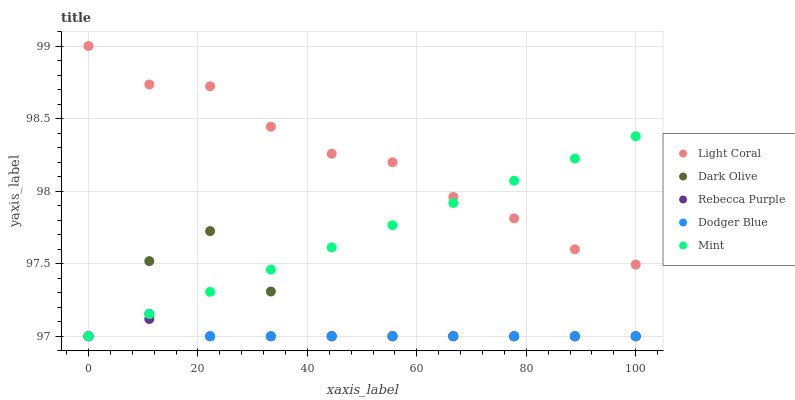Does Rebecca Purple have the minimum area under the curve?
Answer yes or no. Yes. Does Light Coral have the maximum area under the curve?
Answer yes or no. Yes. Does Mint have the minimum area under the curve?
Answer yes or no. No. Does Mint have the maximum area under the curve?
Answer yes or no. No. Is Mint the smoothest?
Answer yes or no. Yes. Is Dark Olive the roughest?
Answer yes or no. Yes. Is Dark Olive the smoothest?
Answer yes or no. No. Is Mint the roughest?
Answer yes or no. No. Does Mint have the lowest value?
Answer yes or no. Yes. Does Light Coral have the highest value?
Answer yes or no. Yes. Does Mint have the highest value?
Answer yes or no. No. Is Rebecca Purple less than Light Coral?
Answer yes or no. Yes. Is Light Coral greater than Rebecca Purple?
Answer yes or no. Yes. Does Dark Olive intersect Dodger Blue?
Answer yes or no. Yes. Is Dark Olive less than Dodger Blue?
Answer yes or no. No. Is Dark Olive greater than Dodger Blue?
Answer yes or no. No. Does Rebecca Purple intersect Light Coral?
Answer yes or no. No. 